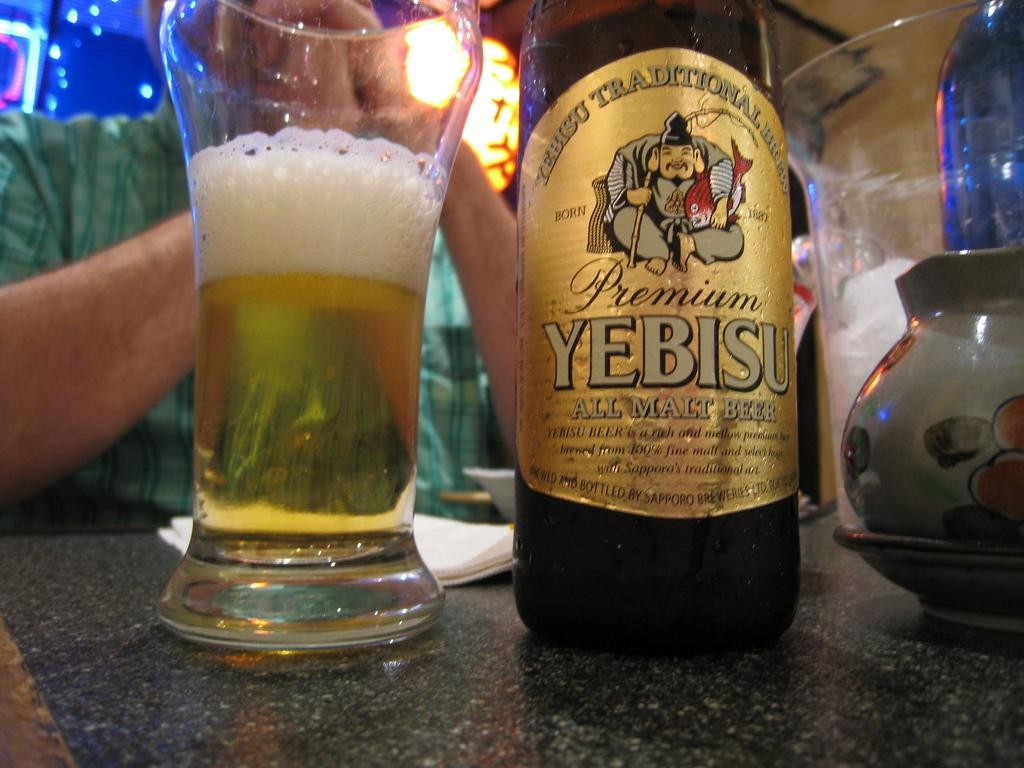Provide a one-sentence caption for the provided image. A bottle of Yebisu malt beer sits next to a glass. 